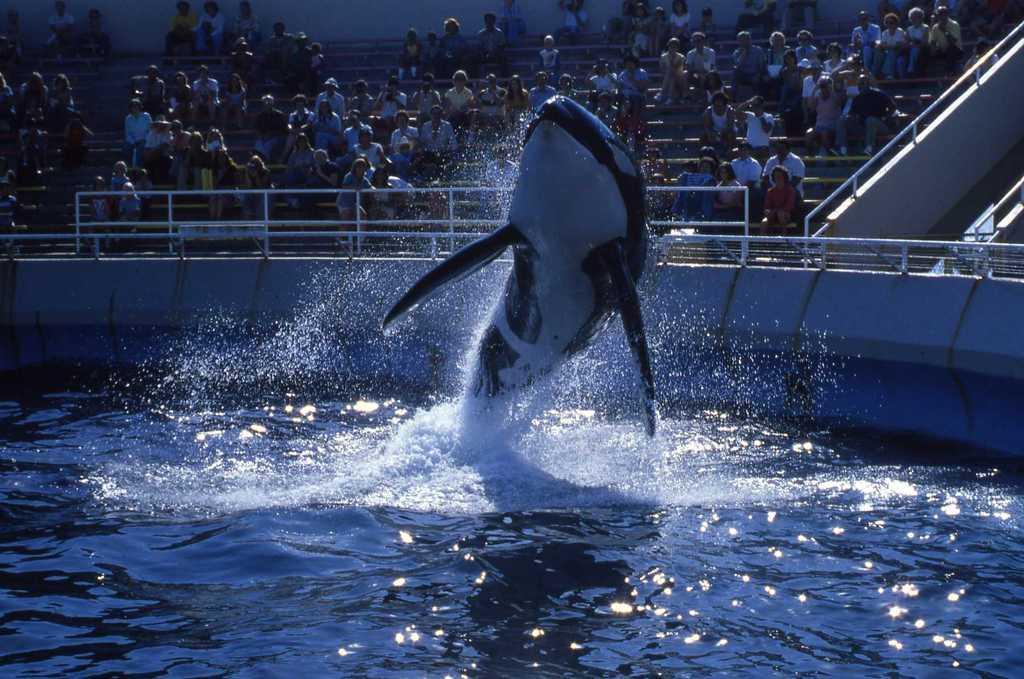In one or two sentences, can you explain what this image depicts? In this image we can see that there is a dolphin coming out from the water. In the background there are so many people sitting in the stands and watching it. There is a fence around the water. At the bottom there is water. 